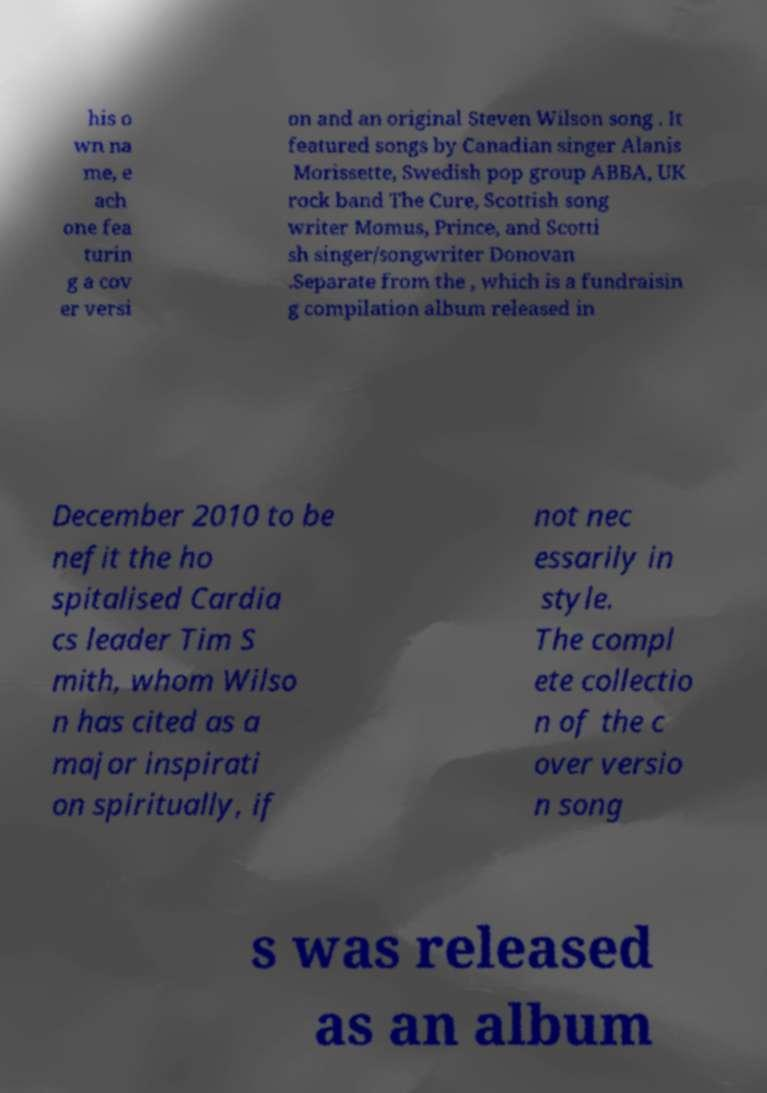For documentation purposes, I need the text within this image transcribed. Could you provide that? his o wn na me, e ach one fea turin g a cov er versi on and an original Steven Wilson song . It featured songs by Canadian singer Alanis Morissette, Swedish pop group ABBA, UK rock band The Cure, Scottish song writer Momus, Prince, and Scotti sh singer/songwriter Donovan .Separate from the , which is a fundraisin g compilation album released in December 2010 to be nefit the ho spitalised Cardia cs leader Tim S mith, whom Wilso n has cited as a major inspirati on spiritually, if not nec essarily in style. The compl ete collectio n of the c over versio n song s was released as an album 